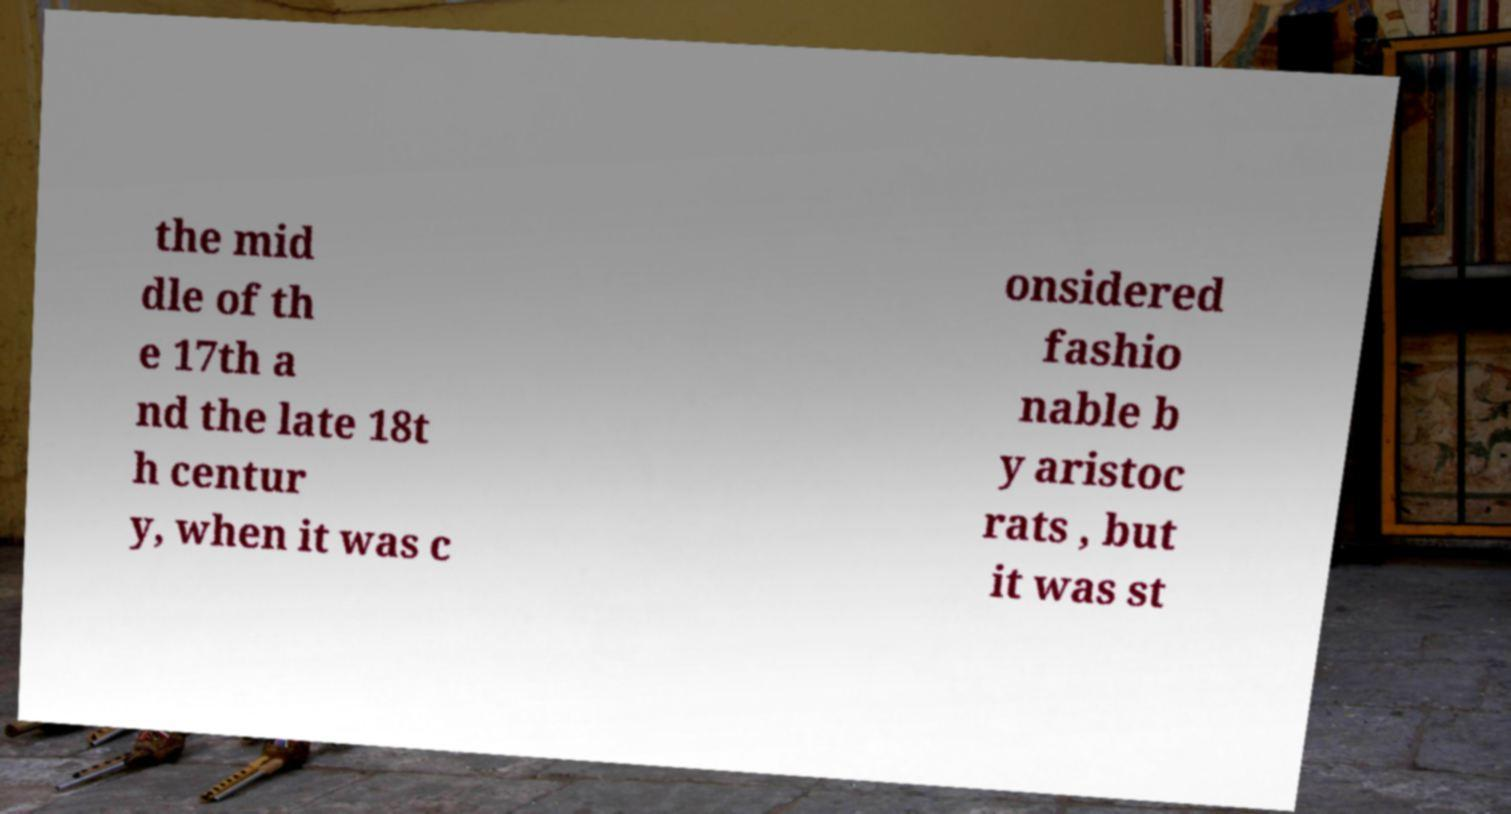For documentation purposes, I need the text within this image transcribed. Could you provide that? the mid dle of th e 17th a nd the late 18t h centur y, when it was c onsidered fashio nable b y aristoc rats , but it was st 